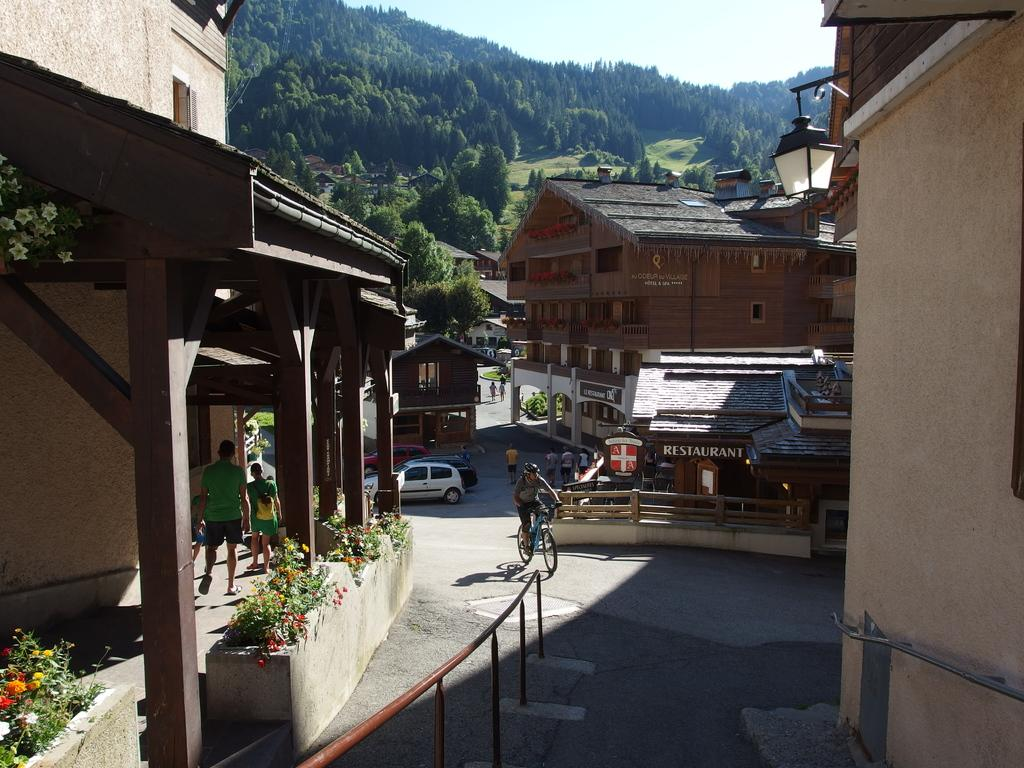Provide a one-sentence caption for the provided image. Small town with a Restaurant  near the back. 